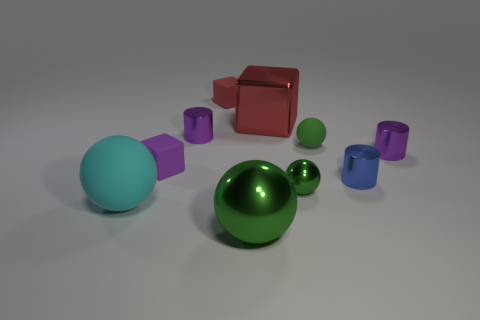Can you associate any mathematical concepts with the objects in this image? Absolutely, this image is a great visual aid for exploring concepts like volume, surface area, and spatial geometry. Each shape represents a classic geometric figure whose properties can be calculated and compared, such as the volume of a sphere versus a cube, or the difference in surface area between a cube and a cylinder. Could the positioning of the objects reveal anything interesting? Indeed, the arrangement might allow us to discuss principles of balance and symmetry. While the objects are scattered, one could imagine rearranging them to explore symmetrical patterns or investigate the center of mass for the entire collection of shapes when placed in different configurations. 